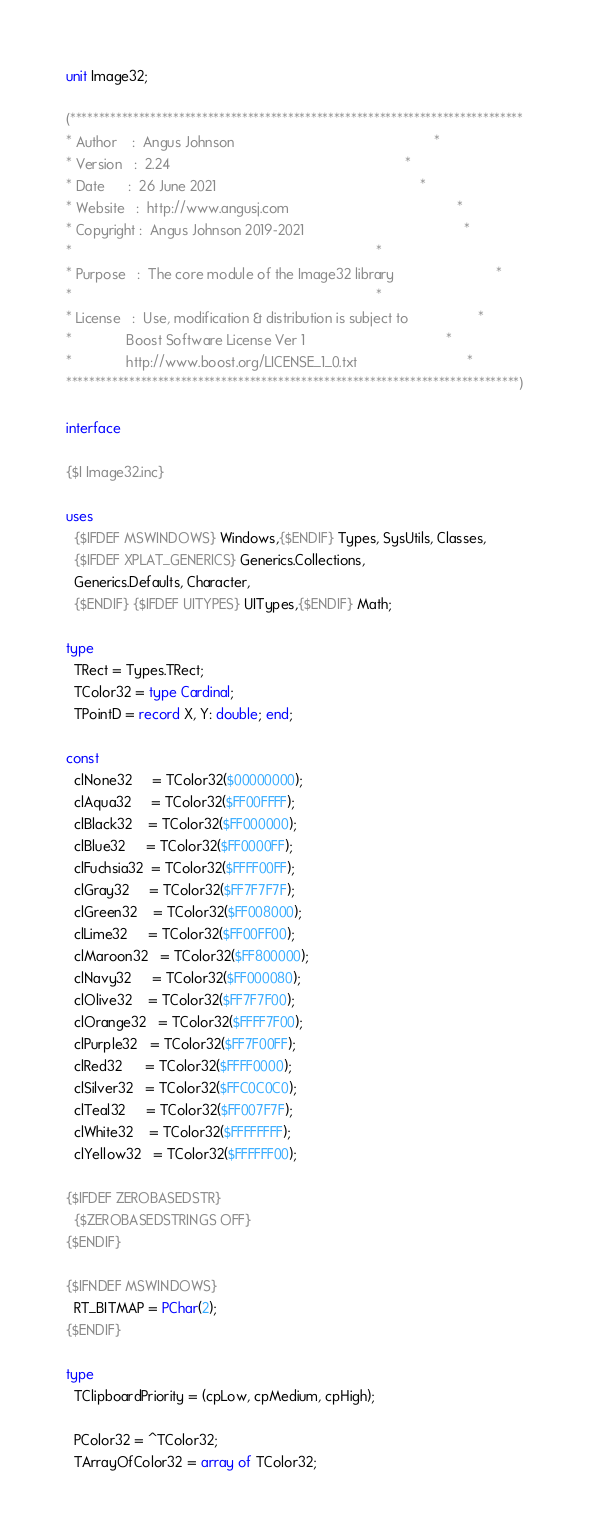<code> <loc_0><loc_0><loc_500><loc_500><_Pascal_>unit Image32;

(*******************************************************************************
* Author    :  Angus Johnson                                                   *
* Version   :  2.24                                                            *
* Date      :  26 June 2021                                                    *
* Website   :  http://www.angusj.com                                           *
* Copyright :  Angus Johnson 2019-2021                                         *
*                                                                              *
* Purpose   :  The core module of the Image32 library                          *
*                                                                              *
* License   :  Use, modification & distribution is subject to                  *
*              Boost Software License Ver 1                                    *
*              http://www.boost.org/LICENSE_1_0.txt                            *
*******************************************************************************)

interface

{$I Image32.inc}

uses
  {$IFDEF MSWINDOWS} Windows,{$ENDIF} Types, SysUtils, Classes,
  {$IFDEF XPLAT_GENERICS} Generics.Collections,
  Generics.Defaults, Character,
  {$ENDIF} {$IFDEF UITYPES} UITypes,{$ENDIF} Math;

type
  TRect = Types.TRect;
  TColor32 = type Cardinal;
  TPointD = record X, Y: double; end;

const
  clNone32     = TColor32($00000000);
  clAqua32     = TColor32($FF00FFFF);
  clBlack32    = TColor32($FF000000);
  clBlue32     = TColor32($FF0000FF);
  clFuchsia32  = TColor32($FFFF00FF);
  clGray32     = TColor32($FF7F7F7F);
  clGreen32    = TColor32($FF008000);
  clLime32     = TColor32($FF00FF00);
  clMaroon32   = TColor32($FF800000);
  clNavy32     = TColor32($FF000080);
  clOlive32    = TColor32($FF7F7F00);
  clOrange32   = TColor32($FFFF7F00);
  clPurple32   = TColor32($FF7F00FF);
  clRed32      = TColor32($FFFF0000);
  clSilver32   = TColor32($FFC0C0C0);
  clTeal32     = TColor32($FF007F7F);
  clWhite32    = TColor32($FFFFFFFF);
  clYellow32   = TColor32($FFFFFF00);

{$IFDEF ZEROBASEDSTR}
  {$ZEROBASEDSTRINGS OFF}
{$ENDIF}

{$IFNDEF MSWINDOWS}
  RT_BITMAP = PChar(2);
{$ENDIF}

type
  TClipboardPriority = (cpLow, cpMedium, cpHigh);

  PColor32 = ^TColor32;
  TArrayOfColor32 = array of TColor32;</code> 